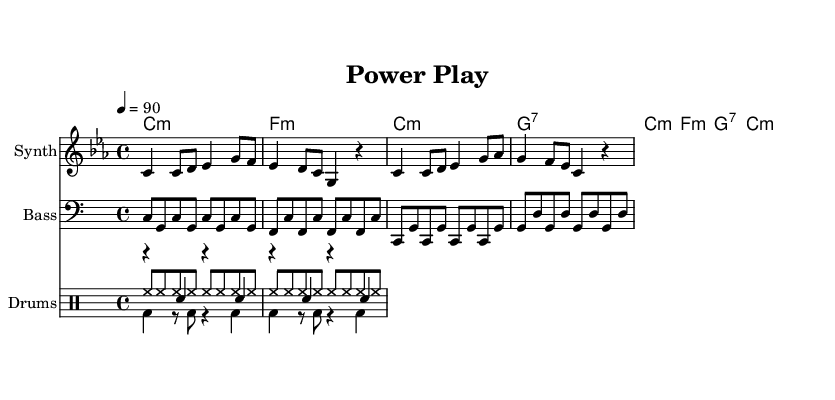what is the key signature of this music? The key signature is C minor, which has three flats (B flat, E flat, and A flat). This can be determined by looking at the clef and the indicated key at the beginning of the score.
Answer: C minor what is the time signature of this music? The time signature is 4/4, which indicates four beats per measure and a quarter note gets one beat. This is evident at the beginning of the piece where the time signature is notated.
Answer: 4/4 what is the tempo marking of the music? The tempo marking indicates that the piece should be played at a speed of 90 beats per minute. The tempo is specified in beats per minute in the beginning section of the score.
Answer: 90 how many measures does the melody have? The melody contains 8 measures, evident by counting the bar lines in the melodic staff. Each segment between the bar lines represents one measure.
Answer: 8 how many different instruments are notated in the score? There are four different instruments notated: Synth (melody), Bass, and Drums (which includes Hi-hat, Kick, and Snare). This can be verified by checking the individual staves and their corresponding instrument names.
Answer: Four what is the primary lyrical theme of the song? The primary lyrical theme addresses political commentary and critiques the actions of politicians, which is evident from the lyrics that reflect on transparency and political promises. This theme can be inferred by analyzing the words in the lyric section.
Answer: Political critique which chord is used at the beginning of the harmonic section? The first chord in the harmonic section is C minor, which can be identified by examining the chord symbols aligned with the bassline and melody in the score.
Answer: C minor 